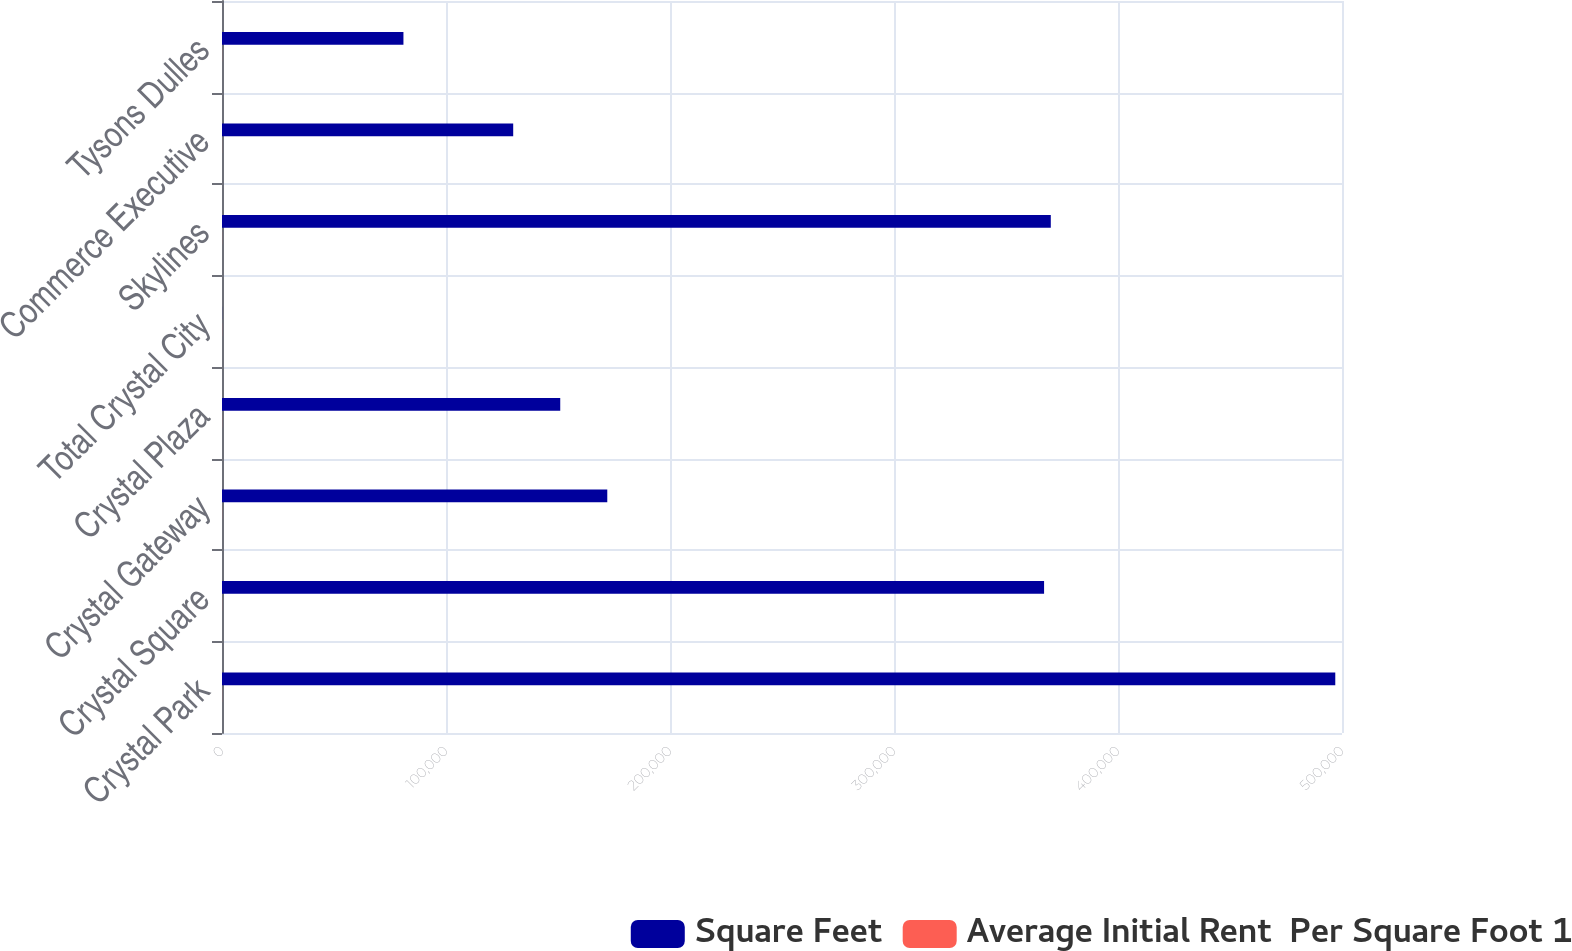<chart> <loc_0><loc_0><loc_500><loc_500><stacked_bar_chart><ecel><fcel>Crystal Park<fcel>Crystal Square<fcel>Crystal Gateway<fcel>Crystal Plaza<fcel>Total Crystal City<fcel>Skylines<fcel>Commerce Executive<fcel>Tysons Dulles<nl><fcel>Square Feet<fcel>497000<fcel>367000<fcel>172000<fcel>151000<fcel>34.45<fcel>370000<fcel>130000<fcel>81000<nl><fcel>Average Initial Rent  Per Square Foot 1<fcel>34.45<fcel>33.29<fcel>34.42<fcel>31.39<fcel>33.7<fcel>28.14<fcel>24.23<fcel>29<nl></chart> 